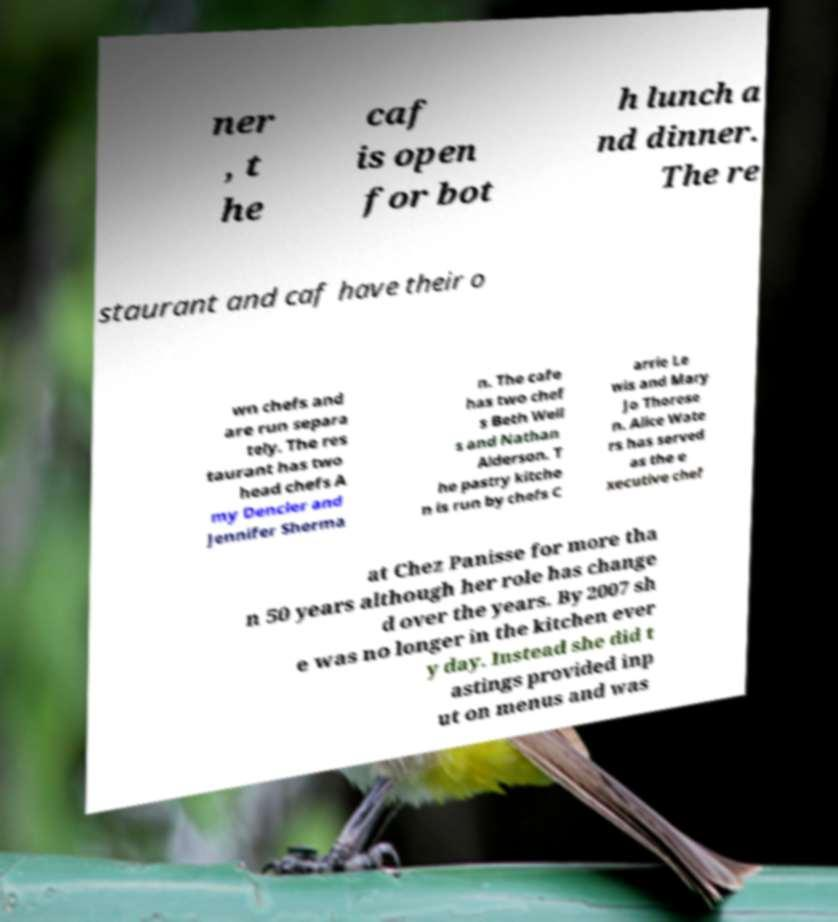Can you accurately transcribe the text from the provided image for me? ner , t he caf is open for bot h lunch a nd dinner. The re staurant and caf have their o wn chefs and are run separa tely. The res taurant has two head chefs A my Dencler and Jennifer Sherma n. The cafe has two chef s Beth Well s and Nathan Alderson. T he pastry kitche n is run by chefs C arrie Le wis and Mary Jo Thorese n. Alice Wate rs has served as the e xecutive chef at Chez Panisse for more tha n 50 years although her role has change d over the years. By 2007 sh e was no longer in the kitchen ever y day. Instead she did t astings provided inp ut on menus and was 